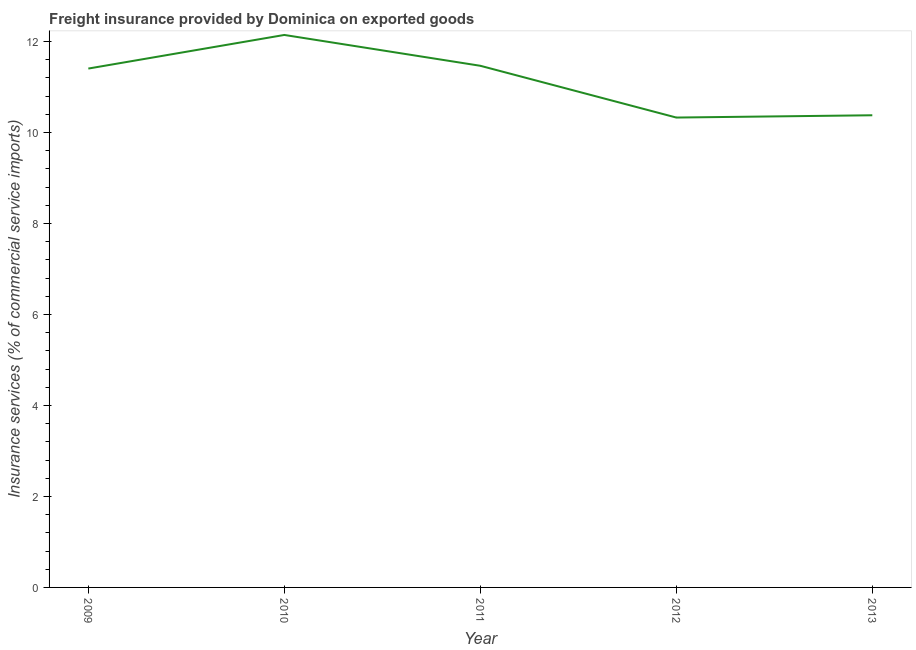What is the freight insurance in 2011?
Your response must be concise. 11.46. Across all years, what is the maximum freight insurance?
Give a very brief answer. 12.14. Across all years, what is the minimum freight insurance?
Provide a short and direct response. 10.33. What is the sum of the freight insurance?
Your response must be concise. 55.71. What is the difference between the freight insurance in 2009 and 2010?
Provide a short and direct response. -0.74. What is the average freight insurance per year?
Offer a terse response. 11.14. What is the median freight insurance?
Make the answer very short. 11.4. Do a majority of the years between 2011 and 2012 (inclusive) have freight insurance greater than 8.8 %?
Your answer should be very brief. Yes. What is the ratio of the freight insurance in 2010 to that in 2013?
Offer a terse response. 1.17. Is the freight insurance in 2010 less than that in 2013?
Provide a short and direct response. No. What is the difference between the highest and the second highest freight insurance?
Ensure brevity in your answer.  0.68. Is the sum of the freight insurance in 2011 and 2013 greater than the maximum freight insurance across all years?
Provide a succinct answer. Yes. What is the difference between the highest and the lowest freight insurance?
Your answer should be compact. 1.82. In how many years, is the freight insurance greater than the average freight insurance taken over all years?
Offer a very short reply. 3. How many lines are there?
Offer a very short reply. 1. How many years are there in the graph?
Your answer should be very brief. 5. What is the difference between two consecutive major ticks on the Y-axis?
Your answer should be very brief. 2. Are the values on the major ticks of Y-axis written in scientific E-notation?
Your answer should be compact. No. Does the graph contain any zero values?
Keep it short and to the point. No. What is the title of the graph?
Give a very brief answer. Freight insurance provided by Dominica on exported goods . What is the label or title of the Y-axis?
Keep it short and to the point. Insurance services (% of commercial service imports). What is the Insurance services (% of commercial service imports) in 2009?
Offer a terse response. 11.4. What is the Insurance services (% of commercial service imports) in 2010?
Provide a short and direct response. 12.14. What is the Insurance services (% of commercial service imports) in 2011?
Ensure brevity in your answer.  11.46. What is the Insurance services (% of commercial service imports) in 2012?
Offer a very short reply. 10.33. What is the Insurance services (% of commercial service imports) in 2013?
Your response must be concise. 10.38. What is the difference between the Insurance services (% of commercial service imports) in 2009 and 2010?
Your answer should be compact. -0.74. What is the difference between the Insurance services (% of commercial service imports) in 2009 and 2011?
Offer a terse response. -0.06. What is the difference between the Insurance services (% of commercial service imports) in 2009 and 2012?
Ensure brevity in your answer.  1.08. What is the difference between the Insurance services (% of commercial service imports) in 2009 and 2013?
Offer a very short reply. 1.03. What is the difference between the Insurance services (% of commercial service imports) in 2010 and 2011?
Provide a short and direct response. 0.68. What is the difference between the Insurance services (% of commercial service imports) in 2010 and 2012?
Ensure brevity in your answer.  1.82. What is the difference between the Insurance services (% of commercial service imports) in 2010 and 2013?
Your response must be concise. 1.77. What is the difference between the Insurance services (% of commercial service imports) in 2011 and 2012?
Provide a short and direct response. 1.14. What is the difference between the Insurance services (% of commercial service imports) in 2011 and 2013?
Your answer should be compact. 1.09. What is the difference between the Insurance services (% of commercial service imports) in 2012 and 2013?
Ensure brevity in your answer.  -0.05. What is the ratio of the Insurance services (% of commercial service imports) in 2009 to that in 2010?
Give a very brief answer. 0.94. What is the ratio of the Insurance services (% of commercial service imports) in 2009 to that in 2011?
Provide a short and direct response. 0.99. What is the ratio of the Insurance services (% of commercial service imports) in 2009 to that in 2012?
Give a very brief answer. 1.1. What is the ratio of the Insurance services (% of commercial service imports) in 2009 to that in 2013?
Your answer should be compact. 1.1. What is the ratio of the Insurance services (% of commercial service imports) in 2010 to that in 2011?
Give a very brief answer. 1.06. What is the ratio of the Insurance services (% of commercial service imports) in 2010 to that in 2012?
Make the answer very short. 1.18. What is the ratio of the Insurance services (% of commercial service imports) in 2010 to that in 2013?
Provide a short and direct response. 1.17. What is the ratio of the Insurance services (% of commercial service imports) in 2011 to that in 2012?
Provide a succinct answer. 1.11. What is the ratio of the Insurance services (% of commercial service imports) in 2011 to that in 2013?
Offer a very short reply. 1.1. What is the ratio of the Insurance services (% of commercial service imports) in 2012 to that in 2013?
Keep it short and to the point. 0.99. 